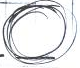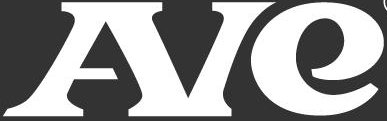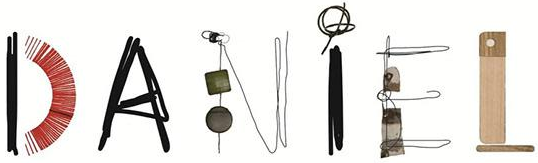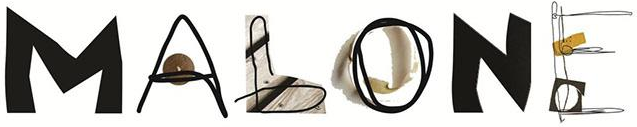Transcribe the words shown in these images in order, separated by a semicolon. .; AIe; DANiEL; MALONE 